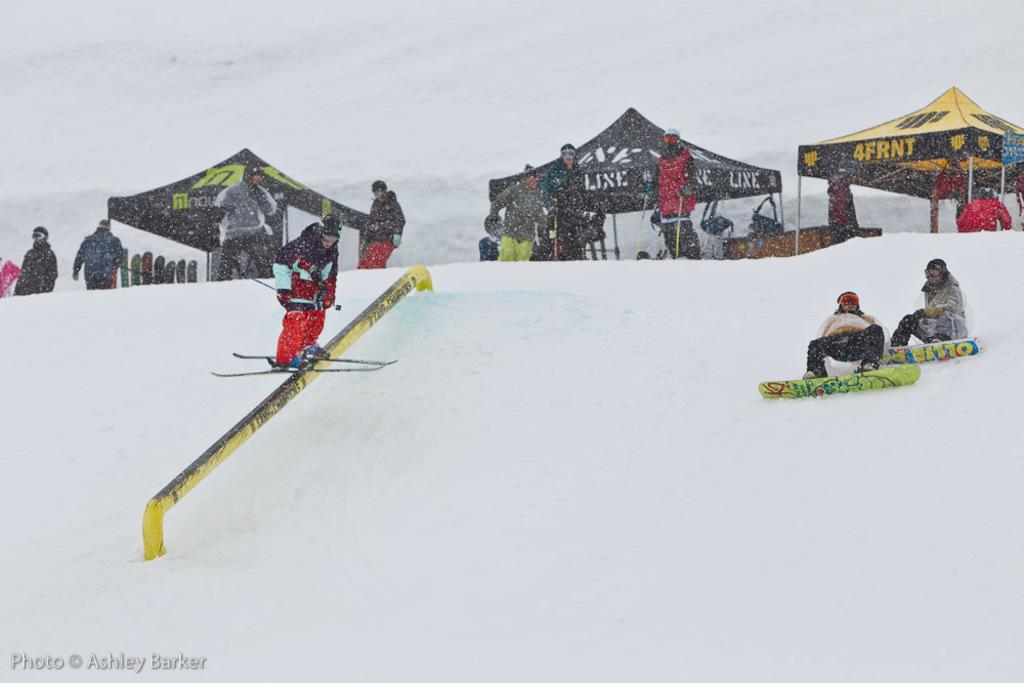What is the condition of the land in the image? The land is covered with snow. What activity is the person in the image engaged in? There is a person riding skis in the image. How many people are present in the image? There are people present in the image. What type of shelter is visible in the image? There are tents in the image. What other winter sports equipment can be seen in the image? Snowboards are visible in the image. What type of gun is being used by the person riding skis in the image? There is no gun present in the image; the person is riding skis. How many rings are visible on the snowboard in the image? There are no rings visible on the snowboard in the image; only the snowboard itself is present. 